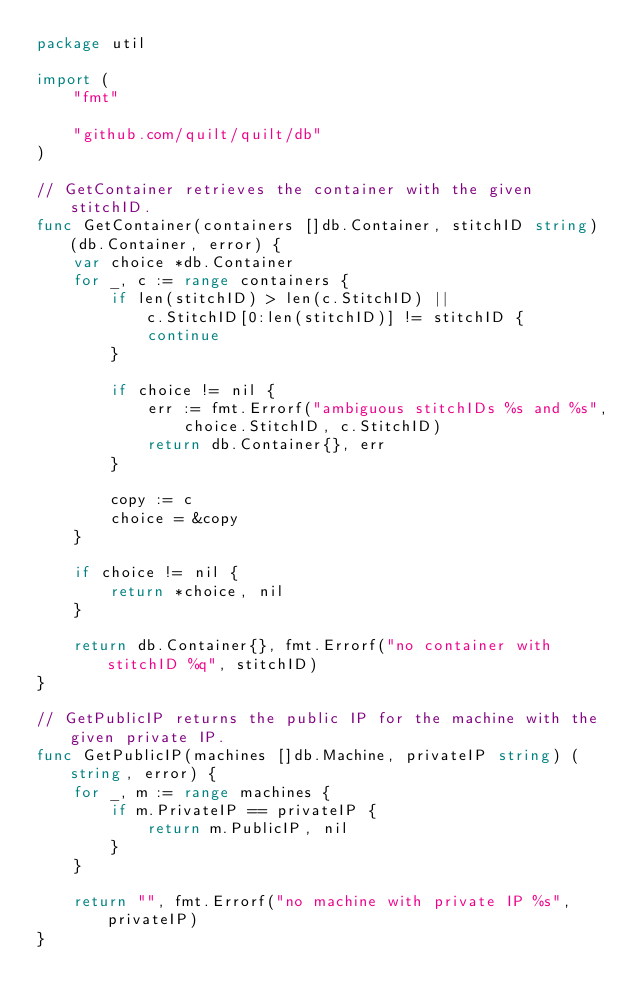<code> <loc_0><loc_0><loc_500><loc_500><_Go_>package util

import (
	"fmt"

	"github.com/quilt/quilt/db"
)

// GetContainer retrieves the container with the given stitchID.
func GetContainer(containers []db.Container, stitchID string) (db.Container, error) {
	var choice *db.Container
	for _, c := range containers {
		if len(stitchID) > len(c.StitchID) ||
			c.StitchID[0:len(stitchID)] != stitchID {
			continue
		}

		if choice != nil {
			err := fmt.Errorf("ambiguous stitchIDs %s and %s",
				choice.StitchID, c.StitchID)
			return db.Container{}, err
		}

		copy := c
		choice = &copy
	}

	if choice != nil {
		return *choice, nil
	}

	return db.Container{}, fmt.Errorf("no container with stitchID %q", stitchID)
}

// GetPublicIP returns the public IP for the machine with the given private IP.
func GetPublicIP(machines []db.Machine, privateIP string) (string, error) {
	for _, m := range machines {
		if m.PrivateIP == privateIP {
			return m.PublicIP, nil
		}
	}

	return "", fmt.Errorf("no machine with private IP %s", privateIP)
}
</code> 